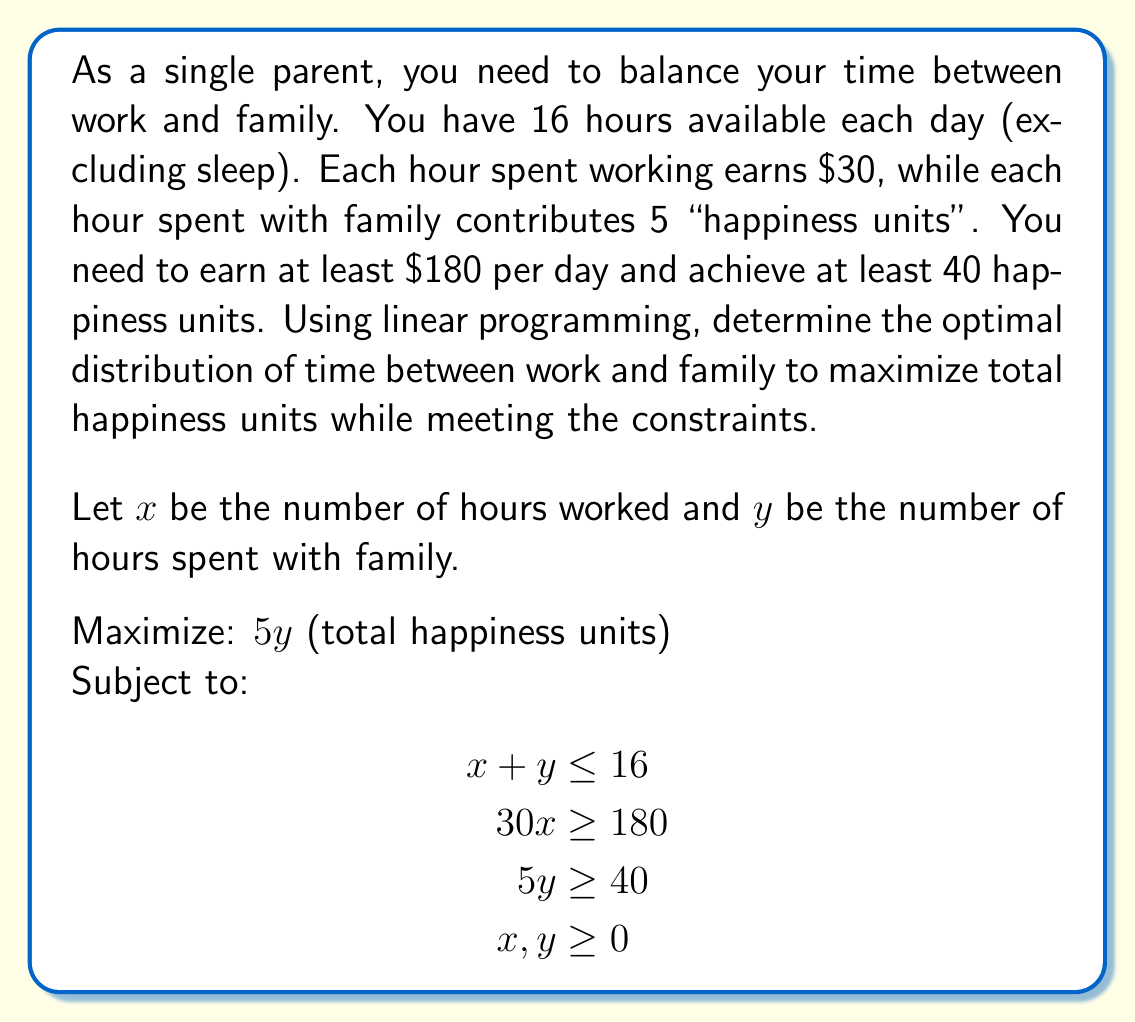Show me your answer to this math problem. Let's solve this step-by-step using the simplex method:

1) First, convert the problem to standard form:
   Maximize: $z = 0x + 5y$
   Subject to:
   $$\begin{align}
   x + y + s_1 &= 16 \\
   30x - s_2 &= 180 \\
   5y - s_3 &= 40 \\
   x, y, s_1, s_2, s_3 &\geq 0
   \end{align}$$

2) Create the initial simplex tableau:
   $$\begin{array}{c|cccc|c}
   & x & y & s_1 & s_2 & s_3 & RHS \\
   \hline
   z & 0 & 5 & 0 & 0 & 0 & 0 \\
   s_1 & 1 & 1 & 1 & 0 & 0 & 16 \\
   x & 30 & 0 & 0 & -1 & 0 & 180 \\
   s_3 & 0 & 5 & 0 & 0 & -1 & 40 \\
   \end{array}$$

3) The most negative entry in the z-row is -5, so y enters the basis.
   The minimum ratio test selects the s_3 row as the pivot row.

4) After pivoting, we get:
   $$\begin{array}{c|cccc|c}
   & x & y & s_1 & s_2 & s_3 & RHS \\
   \hline
   z & 0 & 0 & 0 & 0 & 1 & 40 \\
   s_1 & 1 & 0 & 1 & 0 & 1/5 & 8 \\
   x & 30 & 0 & 0 & -1 & 0 & 180 \\
   y & 0 & 1 & 0 & 0 & -1/5 & 8 \\
   \end{array}$$

5) There are no more negative entries in the z-row, so we've reached optimality.

6) From the final tableau, we can read the solution:
   $x = 6$ (hours worked)
   $y = 8$ (hours with family)
   $z = 40$ (maximum happiness units)

This solution satisfies all constraints:
- Total time: $6 + 8 = 14 \leq 16$
- Earnings: $30 * 6 = 180 \geq 180$
- Happiness: $5 * 8 = 40 \geq 40$
Answer: 6 hours work, 8 hours family 